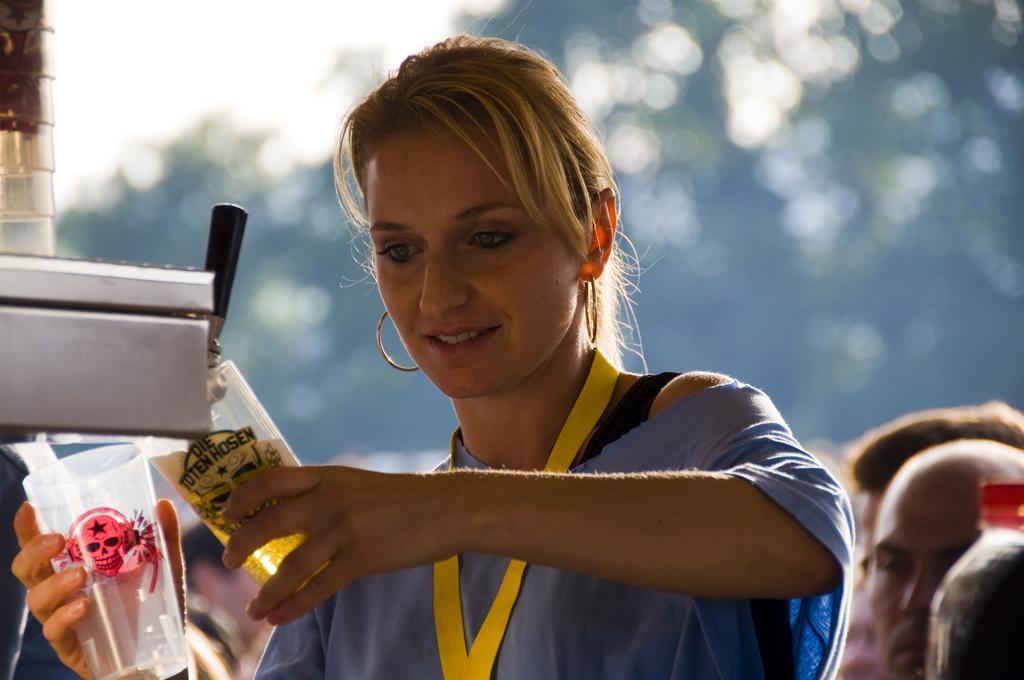Please provide a concise description of this image. This is a woman standing and smiling. She is holding two glasses and filling it with the liquid. This looks like a machine. I can see few people standing. The background looks blurry. 